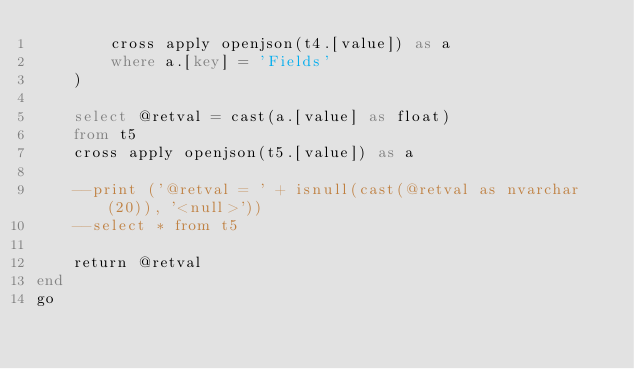Convert code to text. <code><loc_0><loc_0><loc_500><loc_500><_SQL_>		cross apply openjson(t4.[value]) as a
		where a.[key] = 'Fields'
	)

	select @retval = cast(a.[value] as float)
	from t5
	cross apply openjson(t5.[value]) as a

	--print ('@retval = ' + isnull(cast(@retval as nvarchar(20)), '<null>'))
	--select * from t5

	return @retval
end
go

</code> 